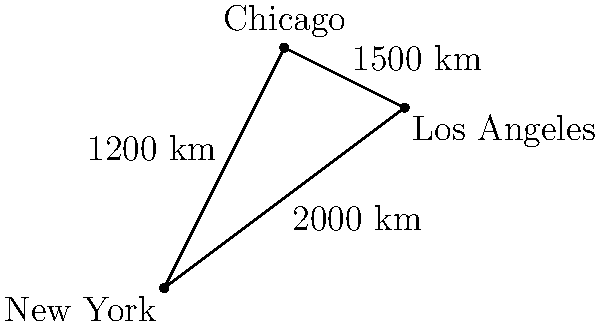As you take a break from your late-night painting session, you ponder the digital world's connectivity. Given a network where New York, Los Angeles, and Chicago are represented by nodes, and the distances between them are shown on the map, calculate the total network latency for a data packet traveling from New York to Los Angeles via Chicago. Assume the network latency is 5 microseconds per 100 km traveled. To solve this problem, we'll follow these steps:

1. Calculate the total distance traveled:
   New York to Chicago: 1200 km
   Chicago to Los Angeles: 1500 km
   Total distance = 1200 km + 1500 km = 2700 km

2. Convert the latency rate to km:
   5 microseconds per 100 km = 0.05 microseconds per km

3. Calculate the total latency:
   Total latency = Total distance × Latency per km
   $$ \text{Total latency} = 2700 \text{ km} \times 0.05 \frac{\mu\text{s}}{\text{km}} = 135 \mu\text{s} $$

Therefore, the total network latency for the data packet traveling from New York to Los Angeles via Chicago is 135 microseconds.
Answer: $135 \mu\text{s}$ 